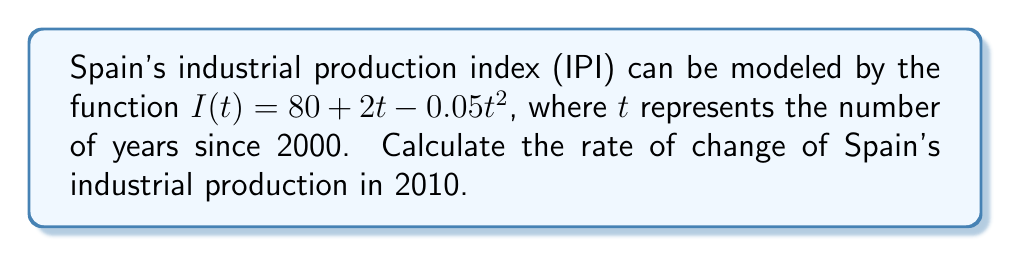Solve this math problem. To solve this problem, we need to follow these steps:

1) First, we need to find the derivative of the given function $I(t)$. This will give us the rate of change of the industrial production index with respect to time.

   $$\frac{dI}{dt} = 2 - 0.1t$$

2) Now, we need to determine the value of $t$ for the year 2010. Since $t$ represents the number of years since 2000, for 2010, $t = 10$.

3) We can now substitute $t = 10$ into our derivative function to find the rate of change in 2010:

   $$\frac{dI}{dt}\bigg|_{t=10} = 2 - 0.1(10) = 2 - 1 = 1$$

4) The units for this rate of change would be the change in the industrial production index per year.

Therefore, in 2010, Spain's industrial production was increasing at a rate of 1 index point per year.
Answer: The rate of change of Spain's industrial production in 2010 was 1 index point per year. 